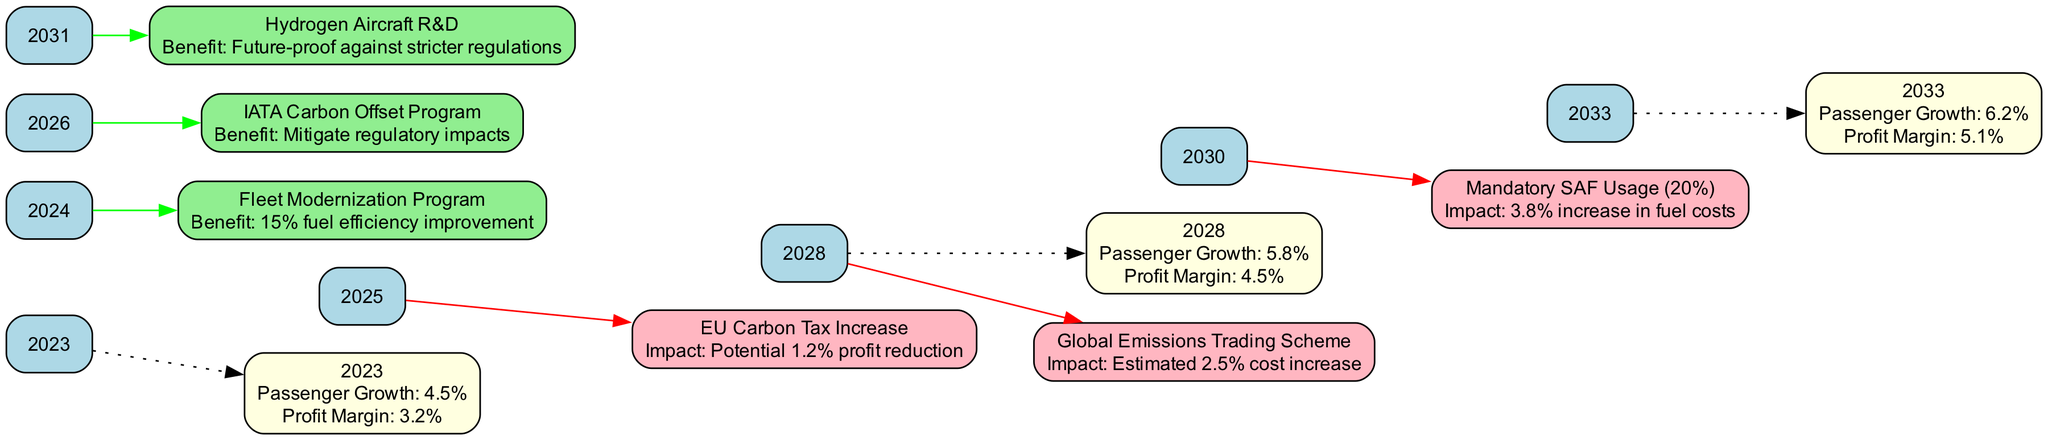What is the projected passenger growth for the year 2033? The diagram shows that the passenger growth for 2033 is 6.2%. This information is presented directly in the growth projections node for that year.
Answer: 6.2% What event is indicated for the year 2028? In the diagram, the regulatory change for 2028 is labeled "Global Emissions Trading Scheme." This is found within the regulatory changes section associated with the year 2028.
Answer: Global Emissions Trading Scheme What impact is associated with the EU Carbon Tax Increase in 2025? The diagram notes that the impact of the EU Carbon Tax Increase in 2025 is a potential 1.2% profit reduction. This information is provided in the events listed under regulatory changes.
Answer: Potential 1.2% profit reduction Which year has a fleet modernization program initiative? According to the diagram, the fleet modernization program initiative is noted for the year 2024. This can be found within the industry initiatives section corresponding to that year.
Answer: 2024 How many industry initiatives are shown in the timeline? The diagram presents three industry initiatives that are listed with specific years. Counting these initiatives confirms that there are indeed three of them.
Answer: 3 What is the projected profit margin for the year 2028? The diagram indicates that the profit margin projected for 2028 is 4.5%. This is shown in the growth projections node for that particular year.
Answer: 4.5% Which initiative has a benefit related to future-proofing against stricter regulations? The diagram highlights the initiative for "Hydrogen Aircraft R&D" in 2031, which is specifically aimed at future-proofing against stricter regulations. This can be located in the industry initiatives section.
Answer: Hydrogen Aircraft R&D What is the estimated cost increase due to the Global Emissions Trading Scheme in 2028? According to the diagram, the estimated cost increase associated with the Global Emissions Trading Scheme in 2028 is 2.5%. This information is provided alongside the regulatory event for that year.
Answer: Estimated 2.5% cost increase What benefit is associated with the IATA Carbon Offset Program in 2026? The diagram indicates that the IATA Carbon Offset Program in 2026 has the benefit of mitigating regulatory impacts. This is included in the description of industry initiatives for that year.
Answer: Mitigate regulatory impacts 